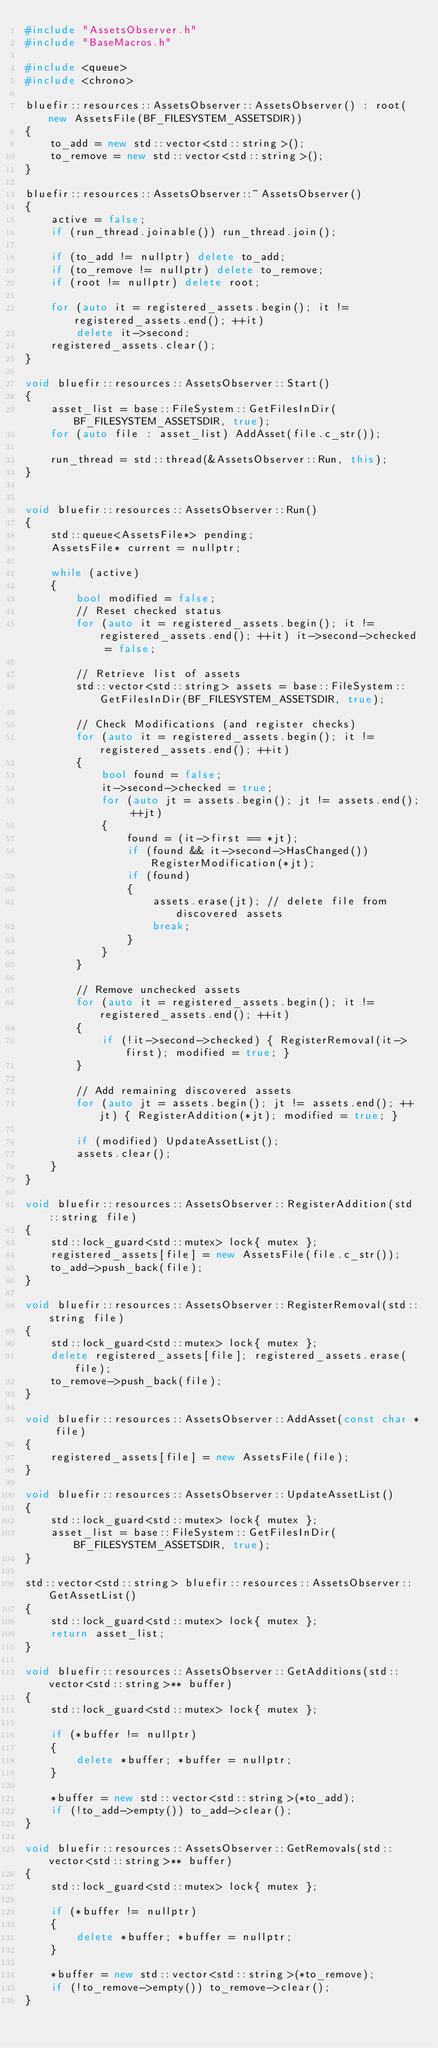Convert code to text. <code><loc_0><loc_0><loc_500><loc_500><_C++_>#include "AssetsObserver.h"
#include "BaseMacros.h"

#include <queue>
#include <chrono>

bluefir::resources::AssetsObserver::AssetsObserver() : root(new AssetsFile(BF_FILESYSTEM_ASSETSDIR))
{
	to_add = new std::vector<std::string>();
	to_remove = new std::vector<std::string>();
}

bluefir::resources::AssetsObserver::~AssetsObserver()
{
	active = false;
	if (run_thread.joinable()) run_thread.join();

	if (to_add != nullptr) delete to_add;
	if (to_remove != nullptr) delete to_remove;
	if (root != nullptr) delete root;

	for (auto it = registered_assets.begin(); it != registered_assets.end(); ++it)
		delete it->second;
	registered_assets.clear();
}

void bluefir::resources::AssetsObserver::Start()
{
	asset_list = base::FileSystem::GetFilesInDir(BF_FILESYSTEM_ASSETSDIR, true);
	for (auto file : asset_list) AddAsset(file.c_str());
	
	run_thread = std::thread(&AssetsObserver::Run, this);
}


void bluefir::resources::AssetsObserver::Run()
{
	std::queue<AssetsFile*> pending;
	AssetsFile* current = nullptr;

	while (active)
	{
		bool modified = false;
		// Reset checked status
		for (auto it = registered_assets.begin(); it != registered_assets.end(); ++it) it->second->checked = false;

		// Retrieve list of assets
		std::vector<std::string> assets = base::FileSystem::GetFilesInDir(BF_FILESYSTEM_ASSETSDIR, true);

		// Check Modifications (and register checks)
		for (auto it = registered_assets.begin(); it != registered_assets.end(); ++it)
		{
			bool found = false;
			it->second->checked = true;
			for (auto jt = assets.begin(); jt != assets.end(); ++jt)
			{
				found = (it->first == *jt);
				if (found && it->second->HasChanged()) RegisterModification(*jt); 
				if (found)
				{
					assets.erase(jt); // delete file from discovered assets
					break;
				}
			}
		}

		// Remove unchecked assets
		for (auto it = registered_assets.begin(); it != registered_assets.end(); ++it)
		{
			if (!it->second->checked) { RegisterRemoval(it->first); modified = true; }
		}

		// Add remaining discovered assets
		for (auto jt = assets.begin(); jt != assets.end(); ++jt) { RegisterAddition(*jt); modified = true; }

		if (modified) UpdateAssetList();
		assets.clear();
	}
}

void bluefir::resources::AssetsObserver::RegisterAddition(std::string file)
{
	std::lock_guard<std::mutex> lock{ mutex };
	registered_assets[file] = new AssetsFile(file.c_str());
	to_add->push_back(file);
}

void bluefir::resources::AssetsObserver::RegisterRemoval(std::string file)
{
	std::lock_guard<std::mutex> lock{ mutex };
	delete registered_assets[file]; registered_assets.erase(file);
	to_remove->push_back(file);
}

void bluefir::resources::AssetsObserver::AddAsset(const char * file)
{
	registered_assets[file] = new AssetsFile(file);
}

void bluefir::resources::AssetsObserver::UpdateAssetList()
{
	std::lock_guard<std::mutex> lock{ mutex };
	asset_list = base::FileSystem::GetFilesInDir(BF_FILESYSTEM_ASSETSDIR, true);
}

std::vector<std::string> bluefir::resources::AssetsObserver::GetAssetList()
{
	std::lock_guard<std::mutex> lock{ mutex };
	return asset_list;
}

void bluefir::resources::AssetsObserver::GetAdditions(std::vector<std::string>** buffer)
{
	std::lock_guard<std::mutex> lock{ mutex };

	if (*buffer != nullptr)
	{
		delete *buffer; *buffer = nullptr;
	}

	*buffer = new std::vector<std::string>(*to_add);
	if (!to_add->empty()) to_add->clear();
}

void bluefir::resources::AssetsObserver::GetRemovals(std::vector<std::string>** buffer)
{
	std::lock_guard<std::mutex> lock{ mutex };

	if (*buffer != nullptr)
	{
		delete *buffer; *buffer = nullptr;
	}

	*buffer = new std::vector<std::string>(*to_remove);
	if (!to_remove->empty()) to_remove->clear();
}
</code> 